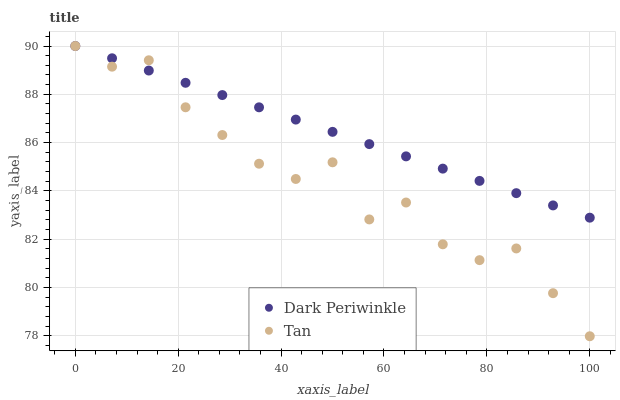Does Tan have the minimum area under the curve?
Answer yes or no. Yes. Does Dark Periwinkle have the maximum area under the curve?
Answer yes or no. Yes. Does Dark Periwinkle have the minimum area under the curve?
Answer yes or no. No. Is Dark Periwinkle the smoothest?
Answer yes or no. Yes. Is Tan the roughest?
Answer yes or no. Yes. Is Dark Periwinkle the roughest?
Answer yes or no. No. Does Tan have the lowest value?
Answer yes or no. Yes. Does Dark Periwinkle have the lowest value?
Answer yes or no. No. Does Dark Periwinkle have the highest value?
Answer yes or no. Yes. Does Tan intersect Dark Periwinkle?
Answer yes or no. Yes. Is Tan less than Dark Periwinkle?
Answer yes or no. No. Is Tan greater than Dark Periwinkle?
Answer yes or no. No. 